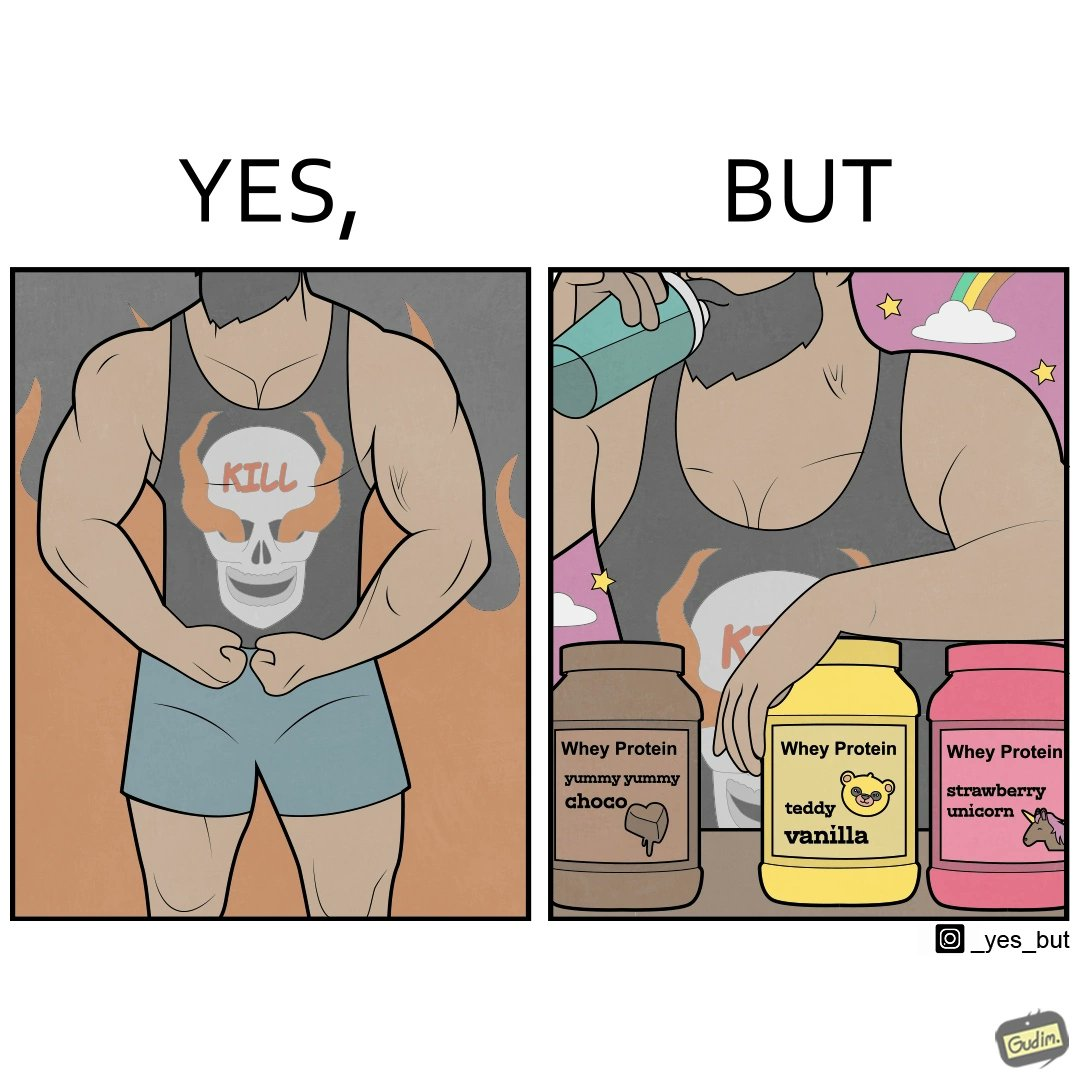What makes this image funny or satirical? The image is funny because a well-built person wearing an aggressive tank-top with the word "KILL" on an image of a skull is having very childish flavours of whey protein such as teddy vanilla, yummy yummy choco, and strawberry vanilla, contrary to the person's external persona. This depicts the metaphor 'Do not judge a book by its cover'. 